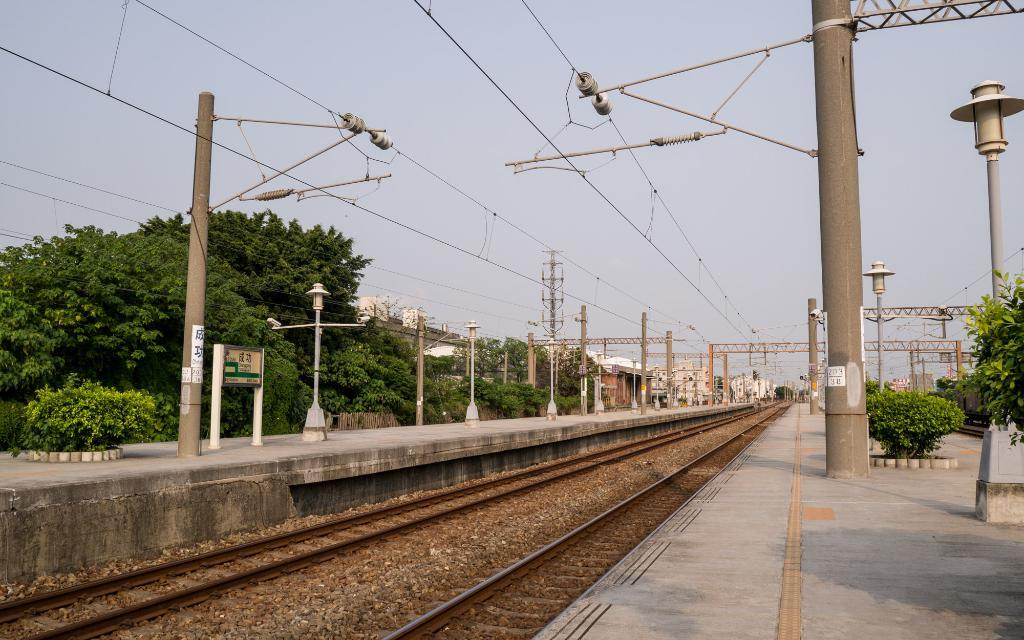What type of transportation infrastructure is present in the image? There is a railway track in the image. What else can be seen near the railway track? There are poles, trees, and a platform visible in the image. What type of structures are present in the image? There are buildings in the image. What can be seen in the background of the image? The sky is visible in the background of the image. How many jellyfish are swimming in the image? There are no jellyfish present in the image; it features a railway track, poles, trees, a platform, buildings, and the sky. 